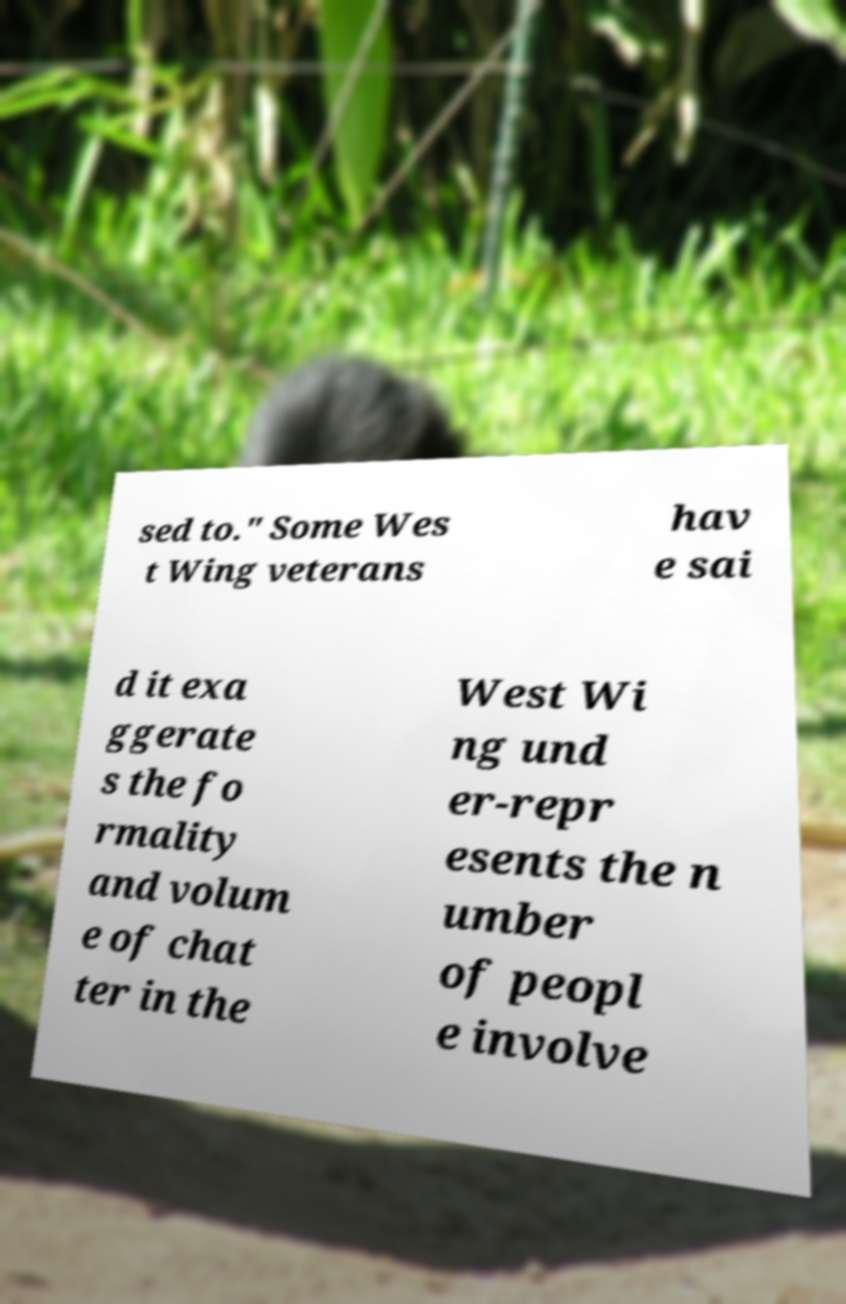Please identify and transcribe the text found in this image. sed to." Some Wes t Wing veterans hav e sai d it exa ggerate s the fo rmality and volum e of chat ter in the West Wi ng und er-repr esents the n umber of peopl e involve 